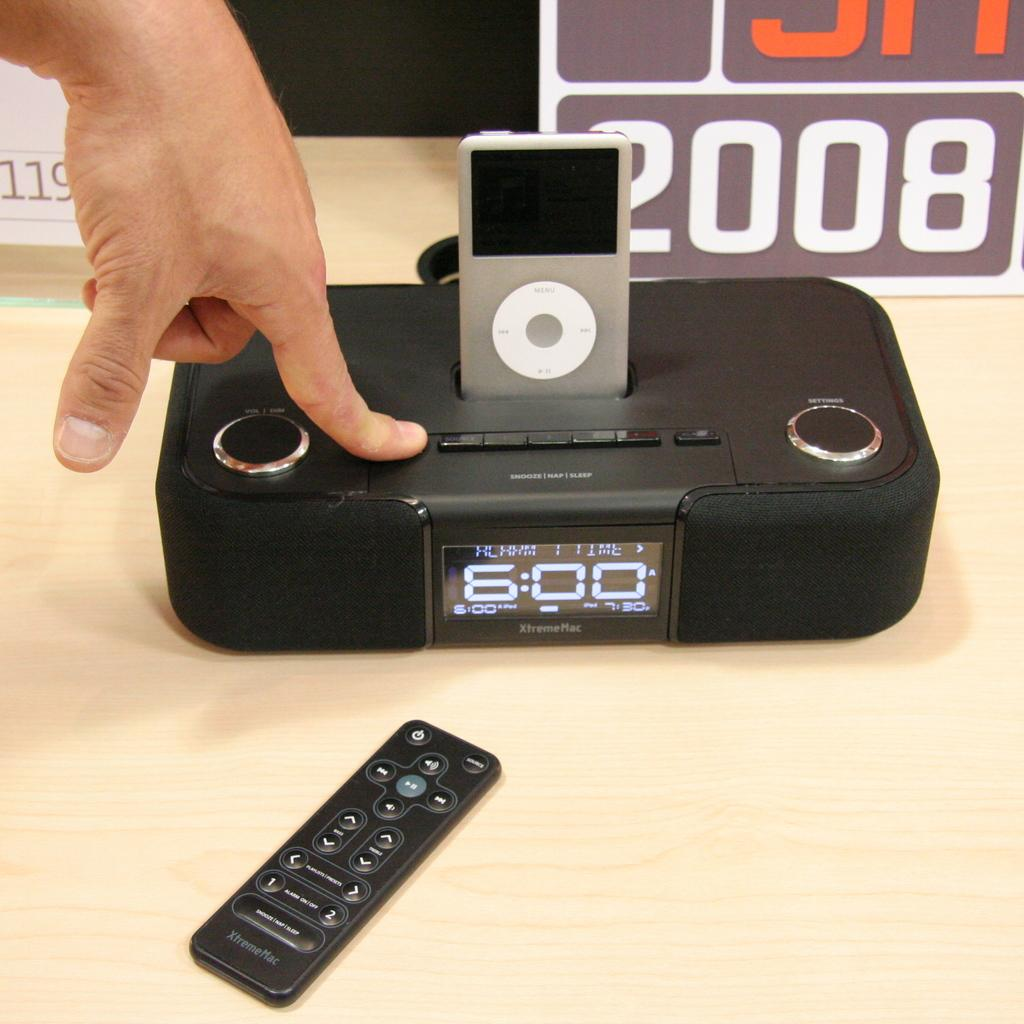<image>
Relay a brief, clear account of the picture shown. The time is 600 on the black charging device 